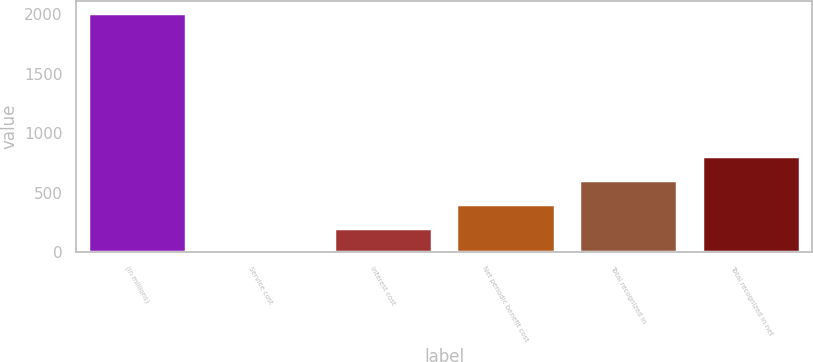<chart> <loc_0><loc_0><loc_500><loc_500><bar_chart><fcel>(in millions)<fcel>Service cost<fcel>Interest cost<fcel>Net periodic benefit cost<fcel>Total recognized in<fcel>Total recognized in net<nl><fcel>2014<fcel>2<fcel>203.2<fcel>404.4<fcel>605.6<fcel>806.8<nl></chart> 